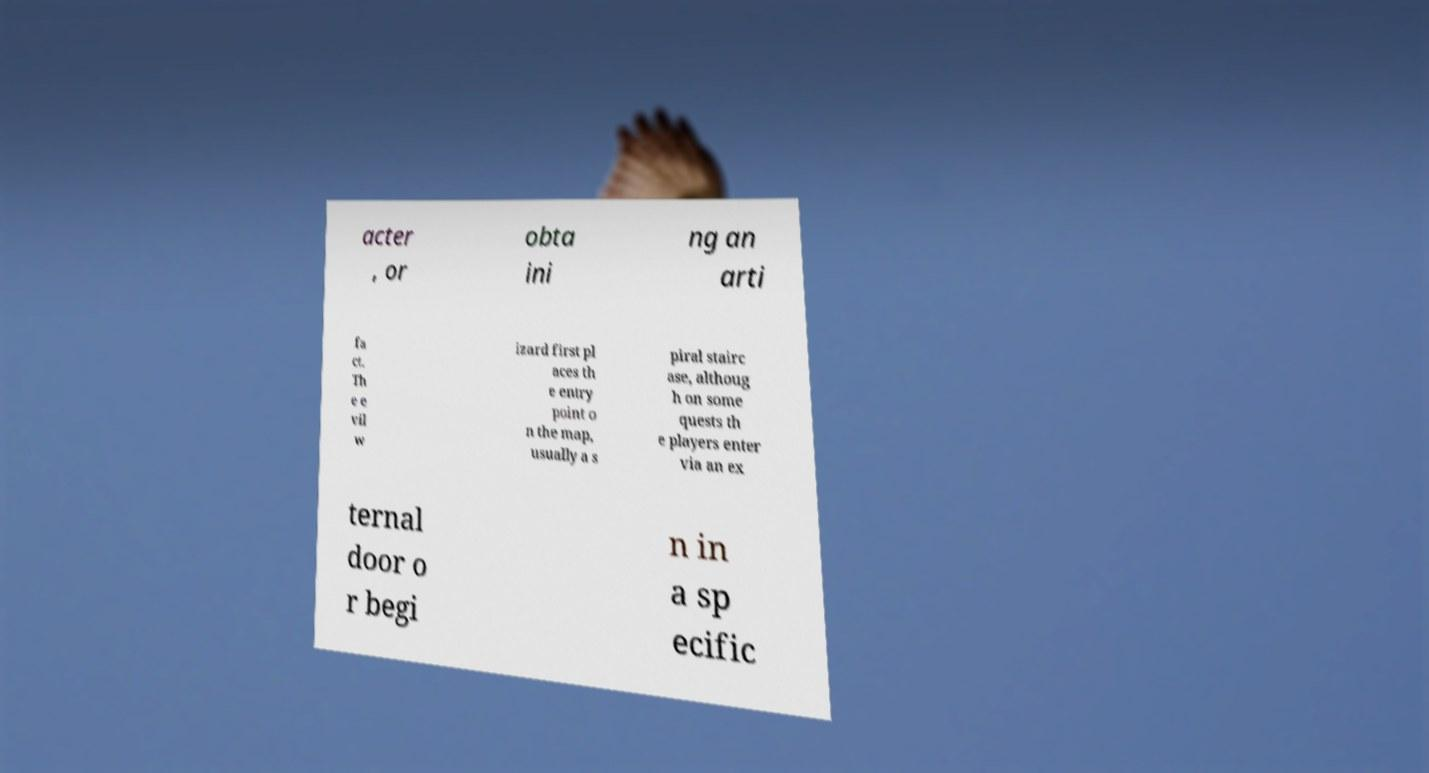Can you read and provide the text displayed in the image?This photo seems to have some interesting text. Can you extract and type it out for me? acter , or obta ini ng an arti fa ct. Th e e vil w izard first pl aces th e entry point o n the map, usually a s piral stairc ase, althoug h on some quests th e players enter via an ex ternal door o r begi n in a sp ecific 